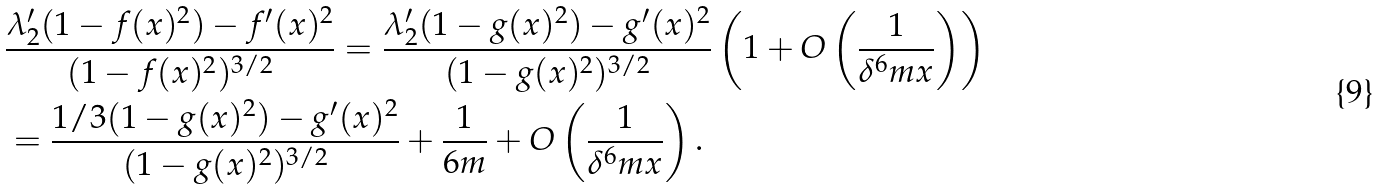Convert formula to latex. <formula><loc_0><loc_0><loc_500><loc_500>& \frac { \lambda _ { 2 } ^ { \prime } ( 1 - f ( x ) ^ { 2 } ) - f ^ { \prime } ( x ) ^ { 2 } } { ( 1 - f ( x ) ^ { 2 } ) ^ { 3 / 2 } } = \frac { \lambda _ { 2 } ^ { \prime } ( 1 - g ( x ) ^ { 2 } ) - g ^ { \prime } ( x ) ^ { 2 } } { ( 1 - g ( x ) ^ { 2 } ) ^ { 3 / 2 } } \left ( 1 + O \left ( \frac { 1 } { \delta ^ { 6 } m x } \right ) \right ) \\ & = \frac { 1 / 3 ( 1 - g ( x ) ^ { 2 } ) - g ^ { \prime } ( x ) ^ { 2 } } { ( 1 - g ( x ) ^ { 2 } ) ^ { 3 / 2 } } + \frac { 1 } { 6 m } + O \left ( \frac { 1 } { \delta ^ { 6 } m x } \right ) .</formula> 